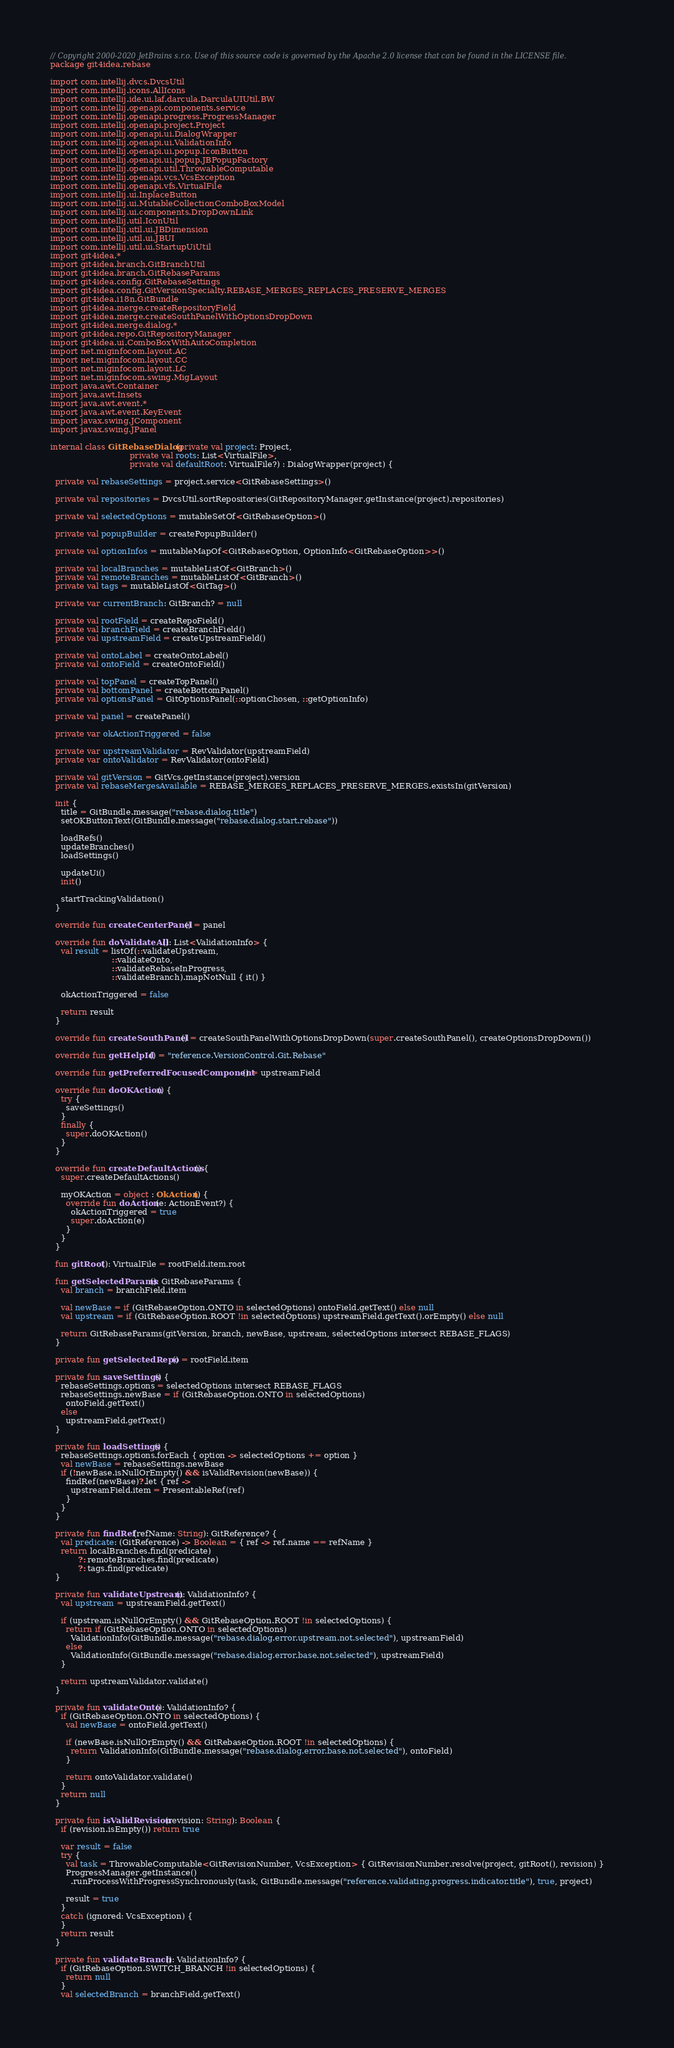<code> <loc_0><loc_0><loc_500><loc_500><_Kotlin_>// Copyright 2000-2020 JetBrains s.r.o. Use of this source code is governed by the Apache 2.0 license that can be found in the LICENSE file.
package git4idea.rebase

import com.intellij.dvcs.DvcsUtil
import com.intellij.icons.AllIcons
import com.intellij.ide.ui.laf.darcula.DarculaUIUtil.BW
import com.intellij.openapi.components.service
import com.intellij.openapi.progress.ProgressManager
import com.intellij.openapi.project.Project
import com.intellij.openapi.ui.DialogWrapper
import com.intellij.openapi.ui.ValidationInfo
import com.intellij.openapi.ui.popup.IconButton
import com.intellij.openapi.ui.popup.JBPopupFactory
import com.intellij.openapi.util.ThrowableComputable
import com.intellij.openapi.vcs.VcsException
import com.intellij.openapi.vfs.VirtualFile
import com.intellij.ui.InplaceButton
import com.intellij.ui.MutableCollectionComboBoxModel
import com.intellij.ui.components.DropDownLink
import com.intellij.util.IconUtil
import com.intellij.util.ui.JBDimension
import com.intellij.util.ui.JBUI
import com.intellij.util.ui.StartupUiUtil
import git4idea.*
import git4idea.branch.GitBranchUtil
import git4idea.branch.GitRebaseParams
import git4idea.config.GitRebaseSettings
import git4idea.config.GitVersionSpecialty.REBASE_MERGES_REPLACES_PRESERVE_MERGES
import git4idea.i18n.GitBundle
import git4idea.merge.createRepositoryField
import git4idea.merge.createSouthPanelWithOptionsDropDown
import git4idea.merge.dialog.*
import git4idea.repo.GitRepositoryManager
import git4idea.ui.ComboBoxWithAutoCompletion
import net.miginfocom.layout.AC
import net.miginfocom.layout.CC
import net.miginfocom.layout.LC
import net.miginfocom.swing.MigLayout
import java.awt.Container
import java.awt.Insets
import java.awt.event.*
import java.awt.event.KeyEvent
import javax.swing.JComponent
import javax.swing.JPanel

internal class GitRebaseDialog(private val project: Project,
                               private val roots: List<VirtualFile>,
                               private val defaultRoot: VirtualFile?) : DialogWrapper(project) {

  private val rebaseSettings = project.service<GitRebaseSettings>()

  private val repositories = DvcsUtil.sortRepositories(GitRepositoryManager.getInstance(project).repositories)

  private val selectedOptions = mutableSetOf<GitRebaseOption>()

  private val popupBuilder = createPopupBuilder()

  private val optionInfos = mutableMapOf<GitRebaseOption, OptionInfo<GitRebaseOption>>()

  private val localBranches = mutableListOf<GitBranch>()
  private val remoteBranches = mutableListOf<GitBranch>()
  private val tags = mutableListOf<GitTag>()

  private var currentBranch: GitBranch? = null

  private val rootField = createRepoField()
  private val branchField = createBranchField()
  private val upstreamField = createUpstreamField()

  private val ontoLabel = createOntoLabel()
  private val ontoField = createOntoField()

  private val topPanel = createTopPanel()
  private val bottomPanel = createBottomPanel()
  private val optionsPanel = GitOptionsPanel(::optionChosen, ::getOptionInfo)

  private val panel = createPanel()

  private var okActionTriggered = false

  private var upstreamValidator = RevValidator(upstreamField)
  private var ontoValidator = RevValidator(ontoField)

  private val gitVersion = GitVcs.getInstance(project).version
  private val rebaseMergesAvailable = REBASE_MERGES_REPLACES_PRESERVE_MERGES.existsIn(gitVersion)

  init {
    title = GitBundle.message("rebase.dialog.title")
    setOKButtonText(GitBundle.message("rebase.dialog.start.rebase"))

    loadRefs()
    updateBranches()
    loadSettings()

    updateUi()
    init()

    startTrackingValidation()
  }

  override fun createCenterPanel() = panel

  override fun doValidateAll(): List<ValidationInfo> {
    val result = listOf(::validateUpstream,
                        ::validateOnto,
                        ::validateRebaseInProgress,
                        ::validateBranch).mapNotNull { it() }

    okActionTriggered = false

    return result
  }

  override fun createSouthPanel() = createSouthPanelWithOptionsDropDown(super.createSouthPanel(), createOptionsDropDown())

  override fun getHelpId() = "reference.VersionControl.Git.Rebase"

  override fun getPreferredFocusedComponent() = upstreamField

  override fun doOKAction() {
    try {
      saveSettings()
    }
    finally {
      super.doOKAction()
    }
  }

  override fun createDefaultActions() {
    super.createDefaultActions()

    myOKAction = object : OkAction() {
      override fun doAction(e: ActionEvent?) {
        okActionTriggered = true
        super.doAction(e)
      }
    }
  }

  fun gitRoot(): VirtualFile = rootField.item.root

  fun getSelectedParams(): GitRebaseParams {
    val branch = branchField.item

    val newBase = if (GitRebaseOption.ONTO in selectedOptions) ontoField.getText() else null
    val upstream = if (GitRebaseOption.ROOT !in selectedOptions) upstreamField.getText().orEmpty() else null

    return GitRebaseParams(gitVersion, branch, newBase, upstream, selectedOptions intersect REBASE_FLAGS)
  }

  private fun getSelectedRepo() = rootField.item

  private fun saveSettings() {
    rebaseSettings.options = selectedOptions intersect REBASE_FLAGS
    rebaseSettings.newBase = if (GitRebaseOption.ONTO in selectedOptions)
      ontoField.getText()
    else
      upstreamField.getText()
  }

  private fun loadSettings() {
    rebaseSettings.options.forEach { option -> selectedOptions += option }
    val newBase = rebaseSettings.newBase
    if (!newBase.isNullOrEmpty() && isValidRevision(newBase)) {
      findRef(newBase)?.let { ref ->
        upstreamField.item = PresentableRef(ref)
      }
    }
  }

  private fun findRef(refName: String): GitReference? {
    val predicate: (GitReference) -> Boolean = { ref -> ref.name == refName }
    return localBranches.find(predicate)
           ?: remoteBranches.find(predicate)
           ?: tags.find(predicate)
  }

  private fun validateUpstream(): ValidationInfo? {
    val upstream = upstreamField.getText()

    if (upstream.isNullOrEmpty() && GitRebaseOption.ROOT !in selectedOptions) {
      return if (GitRebaseOption.ONTO in selectedOptions)
        ValidationInfo(GitBundle.message("rebase.dialog.error.upstream.not.selected"), upstreamField)
      else
        ValidationInfo(GitBundle.message("rebase.dialog.error.base.not.selected"), upstreamField)
    }

    return upstreamValidator.validate()
  }

  private fun validateOnto(): ValidationInfo? {
    if (GitRebaseOption.ONTO in selectedOptions) {
      val newBase = ontoField.getText()

      if (newBase.isNullOrEmpty() && GitRebaseOption.ROOT !in selectedOptions) {
        return ValidationInfo(GitBundle.message("rebase.dialog.error.base.not.selected"), ontoField)
      }

      return ontoValidator.validate()
    }
    return null
  }

  private fun isValidRevision(revision: String): Boolean {
    if (revision.isEmpty()) return true

    var result = false
    try {
      val task = ThrowableComputable<GitRevisionNumber, VcsException> { GitRevisionNumber.resolve(project, gitRoot(), revision) }
      ProgressManager.getInstance()
        .runProcessWithProgressSynchronously(task, GitBundle.message("reference.validating.progress.indicator.title"), true, project)

      result = true
    }
    catch (ignored: VcsException) {
    }
    return result
  }

  private fun validateBranch(): ValidationInfo? {
    if (GitRebaseOption.SWITCH_BRANCH !in selectedOptions) {
      return null
    }
    val selectedBranch = branchField.getText()</code> 